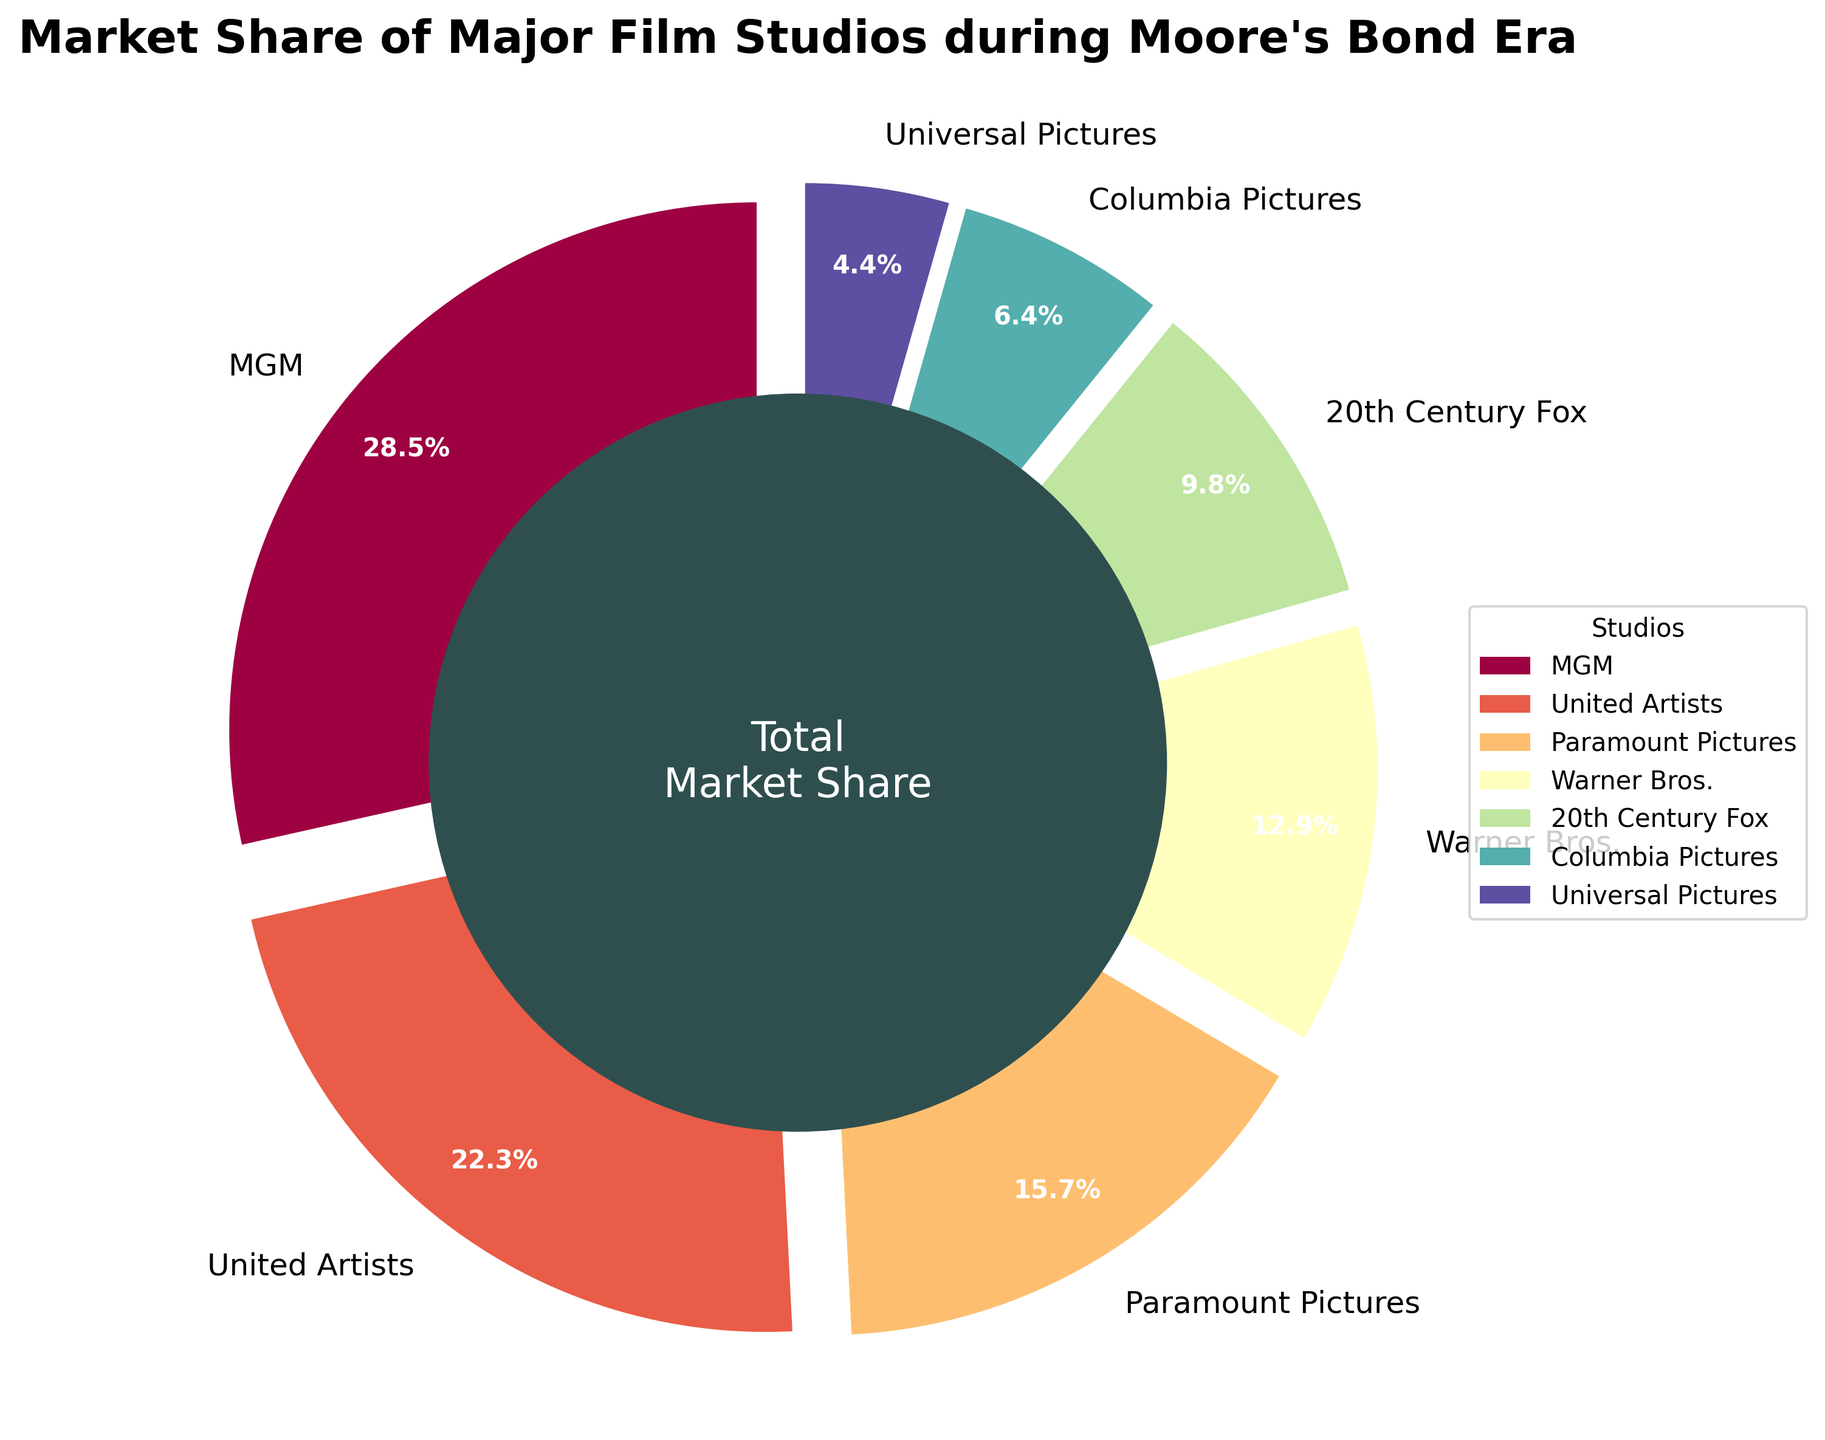What's the highest market share among the film studios? The pie chart reveals that MGM has the largest slice, indicating the highest market share percentage.
Answer: MGM What is the total market share of Paramount Pictures and Warner Bros? Adding the market shares of Paramount Pictures (15.7%) and Warner Bros. (12.9%) gives the total: 15.7 + 12.9 = 28.6%
Answer: 28.6% How much greater is MGM's market share compared to Columbia Pictures'? Subtract Columbia Pictures' market share (6.4%) from MGM's (28.5%) for the difference: 28.5 - 6.4 = 22.1%
Answer: 22.1% Which studio ranks third in terms of market share? By comparing the percentages, Paramount Pictures (15.7%) falls into the third slot after MGM (28.5%) and United Artists (22.3%).
Answer: Paramount Pictures What's the combined market share of the top three studios? Summing up the market shares of MGM (28.5%), United Artists (22.3%), and Paramount Pictures (15.7%): 28.5 + 22.3 + 15.7 = 66.5%
Answer: 66.5% Is Warner Bros.'s market share greater than 20th Century Fox's? Yes, Warner Bros. (12.9%) has a larger market share than 20th Century Fox (9.8%) as indicated by their respective slices in the pie chart.
Answer: Yes What percentage of the market do studios with less than 10% share hold collectively? Adding the market shares of 20th Century Fox (9.8%), Columbia Pictures (6.4%), and Universal Pictures (4.4%): 9.8 + 6.4 + 4.4 = 20.6%
Answer: 20.6% Can you identify the color used for United Artists on the chart? The chart uses a range of colors, and visual inspection identifies United Artists’ slice, usually colored distinctly using a consistent scheme like a reddish hue.
Answer: Reddish (or specific observed color) Which studios combined would give roughly a quarter of the market share? Adding the market shares of Warner Bros. (12.9%) and 20th Century Fox (9.8%) gives close to a quarter: 12.9 + 9.8 = 22.7%
Answer: Warner Bros. and 20th Century Fox 